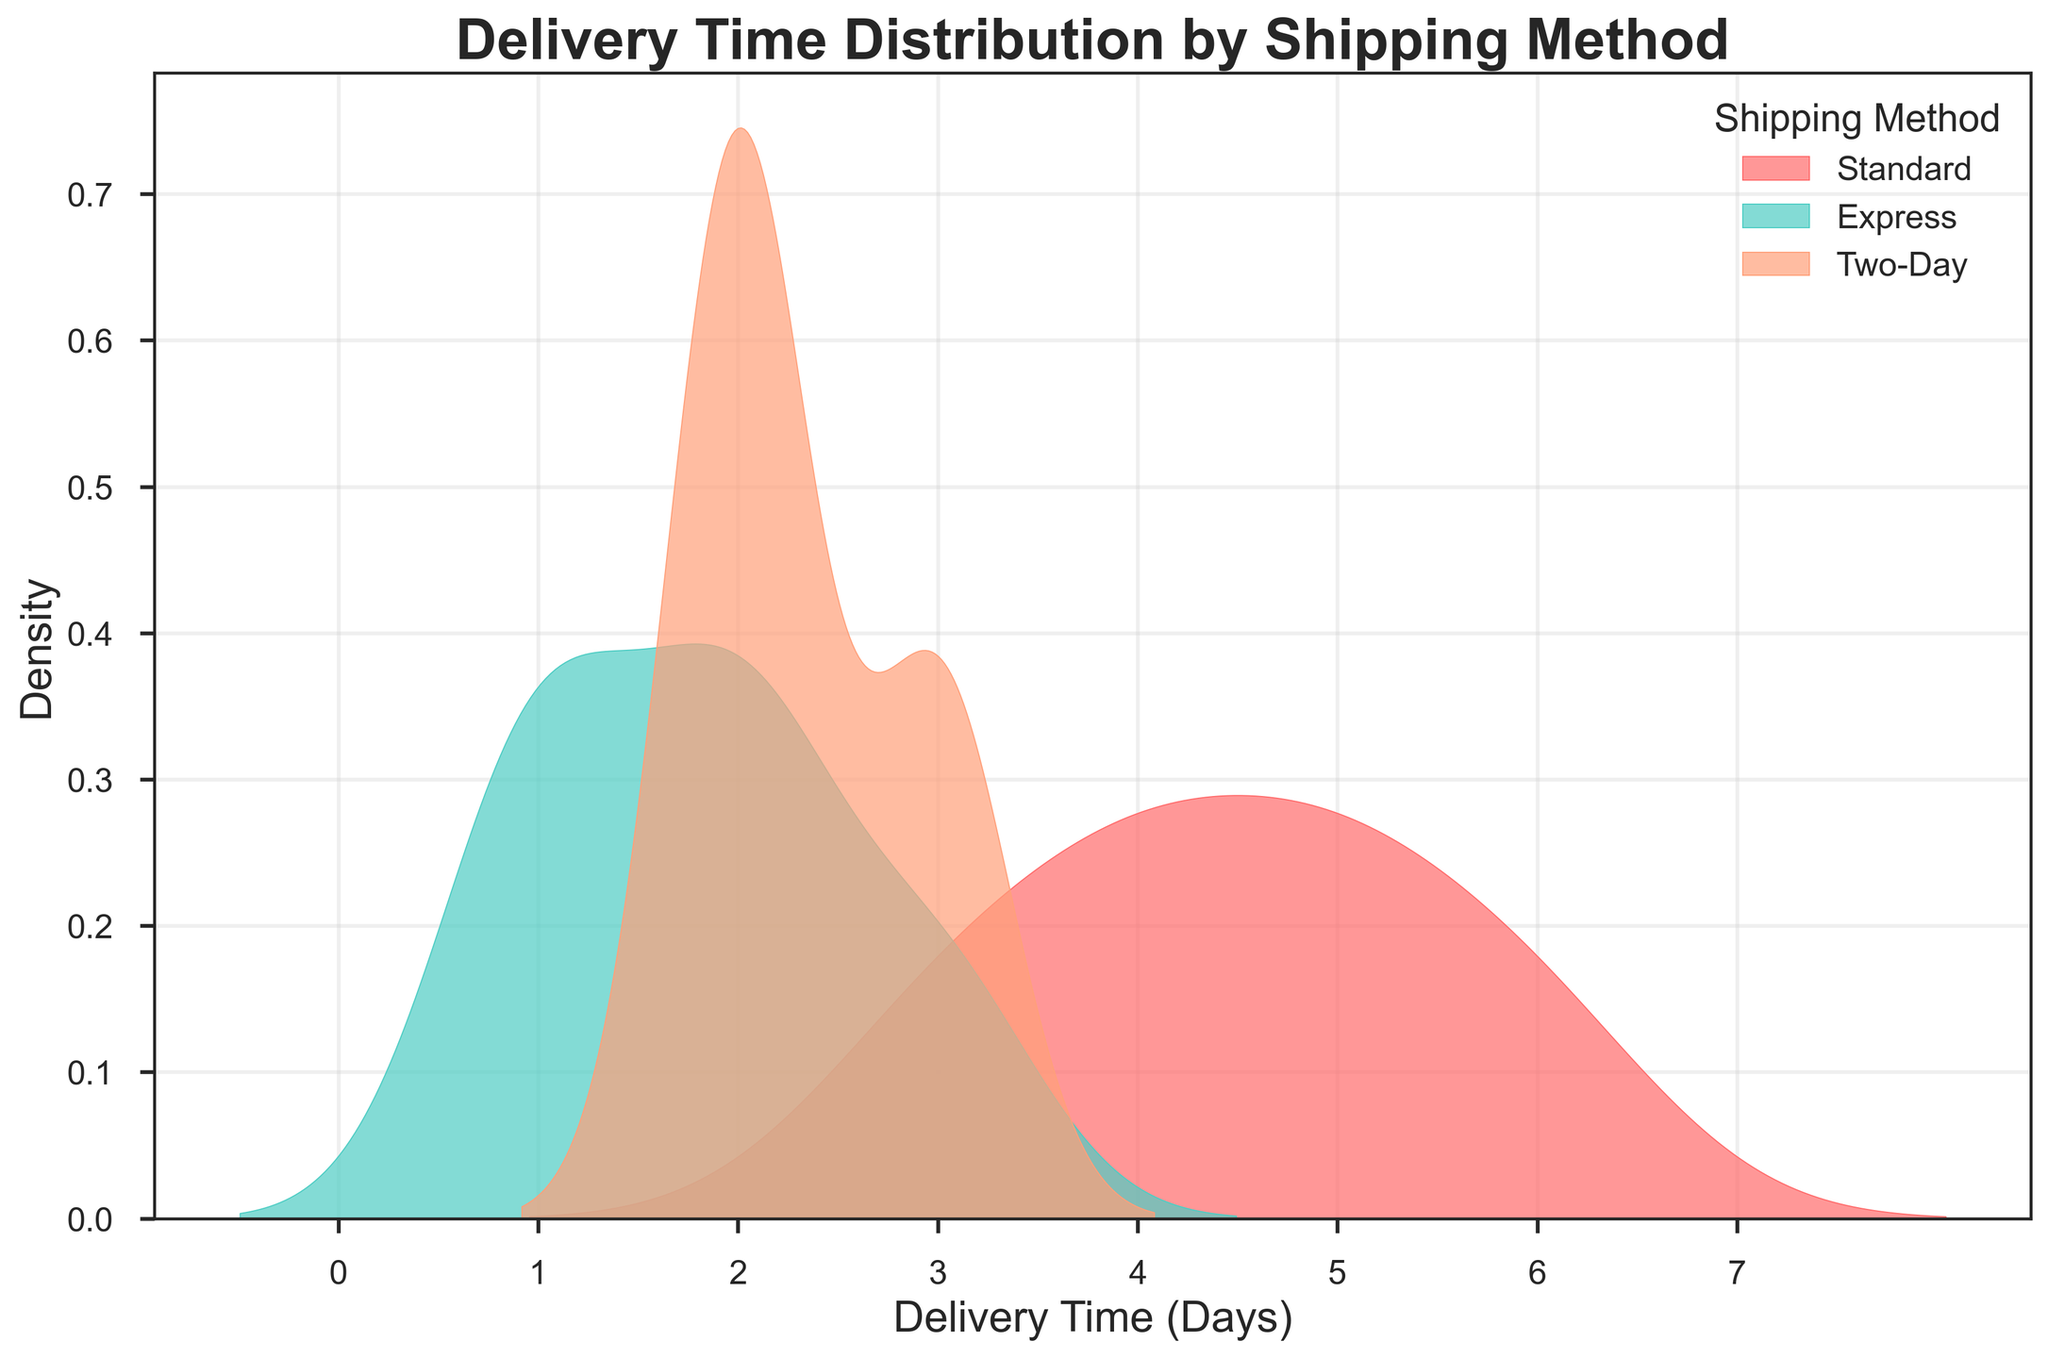What is the delivery time range for the Standard shipping method? Look at the x-axis for the density plot labeled "Standard." The range is determined by the extent of the distribution on the x-axis. The Standard shipping method has delivery times from approximately 3 to 6 days.
Answer: 3 to 6 days Which shipping method has the shortest delivery time distribution peak? Observe the density peaks of the plots. The Overnight shipping method has the highest peak at the shortest delivery time, at around 1 day.
Answer: Overnight How do the delivery times for Express compare with Two-Day shipping? Check the density plots for Express and Two-Day shipping methods. The Express shipping method has delivery times mostly between 1 and 3 days, while Two-Day shipping primarily peaks at 2 and 3 days.
Answer: Express: 1-3 days, Two-Day: 2-3 days Which shipping method shows the most variability in delivery times? Look for the widest spread in the density plots. The Standard shipping method has the highest variability, with delivery times ranging broadly from 3 to 6 days.
Answer: Standard What can be inferred about the consistency of delivery times for the Overnight shipping method? The density plot for Overnight shipping shows a very sharp peak at 1 day and no spread, indicating very consistent delivery times.
Answer: Very consistent Which shipping method has a delivery peak around 2 days? Examine the density plots for peaks around 2 days. Both Express and Two-Day shipping methods have peaks at or around 2 days.
Answer: Express and Two-Day What is the approximate delivery time range covered by the Express and Two-Day shipping methods combined? First, identify the range for each method. Express covers approximately 1 to 3 days, and Two-Day covers approximately 2 to 3 days. Combine these ranges to determine the overall range.
Answer: 1 to 3 days Between the Standard and Express shipping methods, which has a more concentrated (less spread) delivery time distribution? Compare the spread of the density plots for Standard and Express. The Express shipping method has a more concentrated distribution (less spread) compared to the wider spread of Standard.
Answer: Express Are there any overlaps in delivery times between the Standard and Two-Day shipping methods? Look at the range of the density plots for both methods. The delivery times for Standard range from 3 to 6 days, while Two-Day ranges from 2 to 3 days. There is no overlap between these two shipping methods.
Answer: No overlap 